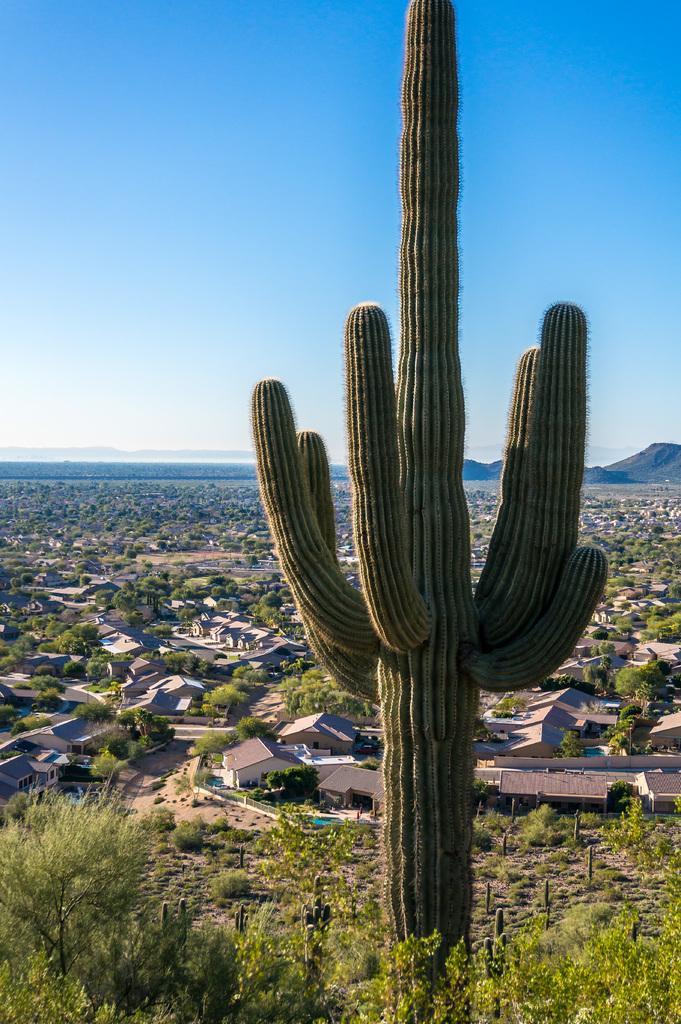Could you give a brief overview of what you see in this image? In this image in the foreground there is one plant, and at the bottom there is some grass and some plants. In the background there are some houses, trees and mountains and at the top of the image there is sky. 